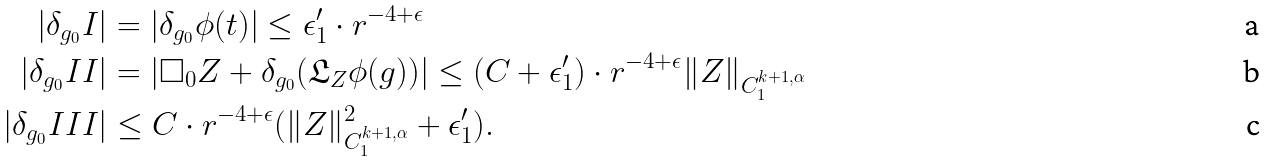<formula> <loc_0><loc_0><loc_500><loc_500>| \delta _ { g _ { 0 } } I | & = | \delta _ { g _ { 0 } } \phi ( t ) | \leq \epsilon _ { 1 } ^ { \prime } \cdot r ^ { - 4 + \epsilon } \\ | \delta _ { g _ { 0 } } I I | & = | \square _ { 0 } Z + \delta _ { g _ { 0 } } ( \mathfrak { L } _ { Z } \phi ( g ) ) | \leq ( C + \epsilon _ { 1 } ^ { \prime } ) \cdot r ^ { - 4 + \epsilon } \| Z \| _ { C ^ { k + 1 , \alpha } _ { 1 } } \\ | \delta _ { g _ { 0 } } I I I | & \leq C \cdot r ^ { - 4 + \epsilon } ( \| Z \| _ { C ^ { k + 1 , \alpha } _ { 1 } } ^ { 2 } + \epsilon _ { 1 } ^ { \prime } ) .</formula> 